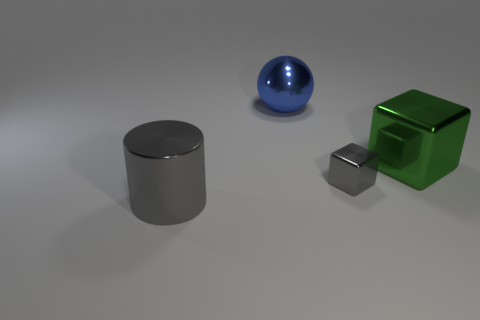Add 4 metallic cylinders. How many objects exist? 8 Subtract all green blocks. How many blocks are left? 1 Subtract all cylinders. How many objects are left? 3 Add 2 big cylinders. How many big cylinders are left? 3 Add 2 green metal cubes. How many green metal cubes exist? 3 Subtract 0 yellow cylinders. How many objects are left? 4 Subtract all cyan blocks. Subtract all yellow cylinders. How many blocks are left? 2 Subtract all metal cylinders. Subtract all balls. How many objects are left? 2 